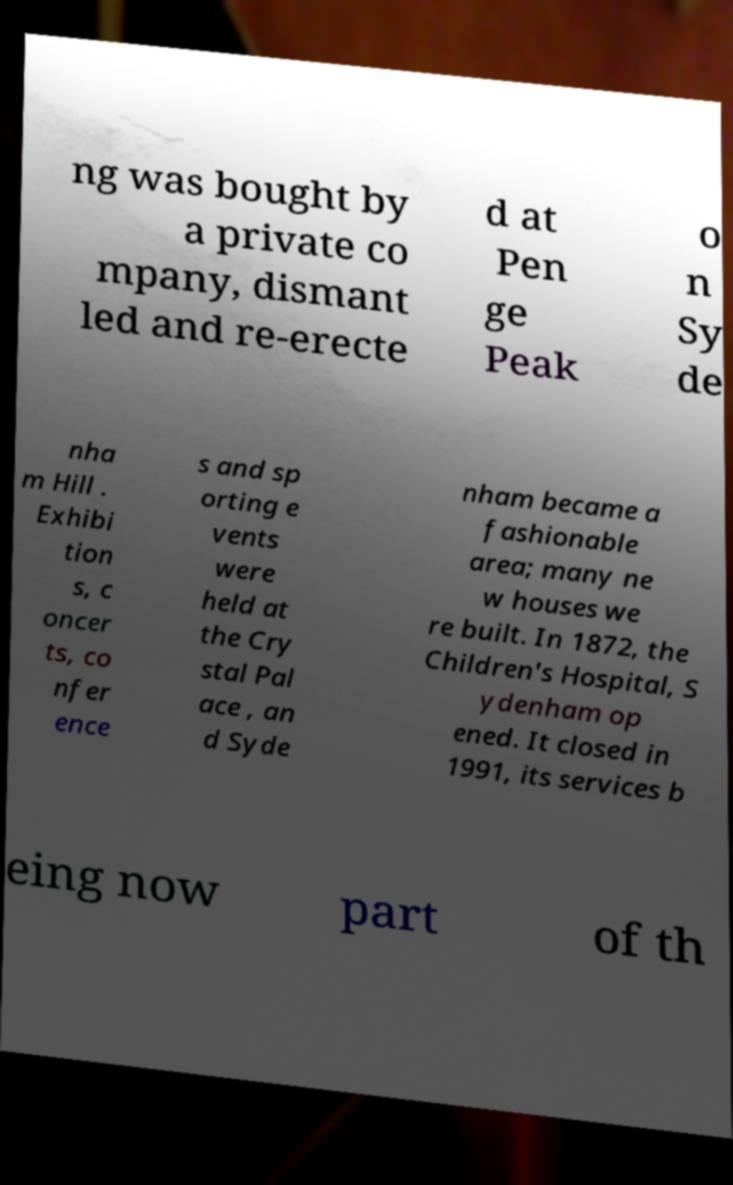For documentation purposes, I need the text within this image transcribed. Could you provide that? ng was bought by a private co mpany, dismant led and re-erecte d at Pen ge Peak o n Sy de nha m Hill . Exhibi tion s, c oncer ts, co nfer ence s and sp orting e vents were held at the Cry stal Pal ace , an d Syde nham became a fashionable area; many ne w houses we re built. In 1872, the Children's Hospital, S ydenham op ened. It closed in 1991, its services b eing now part of th 